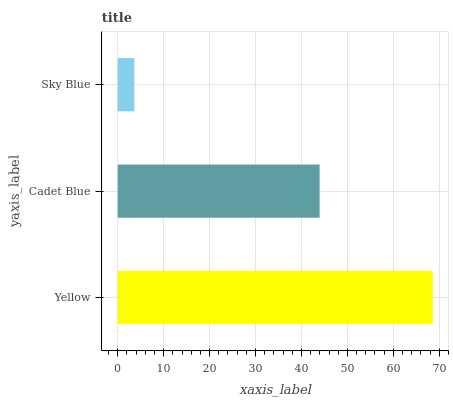Is Sky Blue the minimum?
Answer yes or no. Yes. Is Yellow the maximum?
Answer yes or no. Yes. Is Cadet Blue the minimum?
Answer yes or no. No. Is Cadet Blue the maximum?
Answer yes or no. No. Is Yellow greater than Cadet Blue?
Answer yes or no. Yes. Is Cadet Blue less than Yellow?
Answer yes or no. Yes. Is Cadet Blue greater than Yellow?
Answer yes or no. No. Is Yellow less than Cadet Blue?
Answer yes or no. No. Is Cadet Blue the high median?
Answer yes or no. Yes. Is Cadet Blue the low median?
Answer yes or no. Yes. Is Sky Blue the high median?
Answer yes or no. No. Is Yellow the low median?
Answer yes or no. No. 